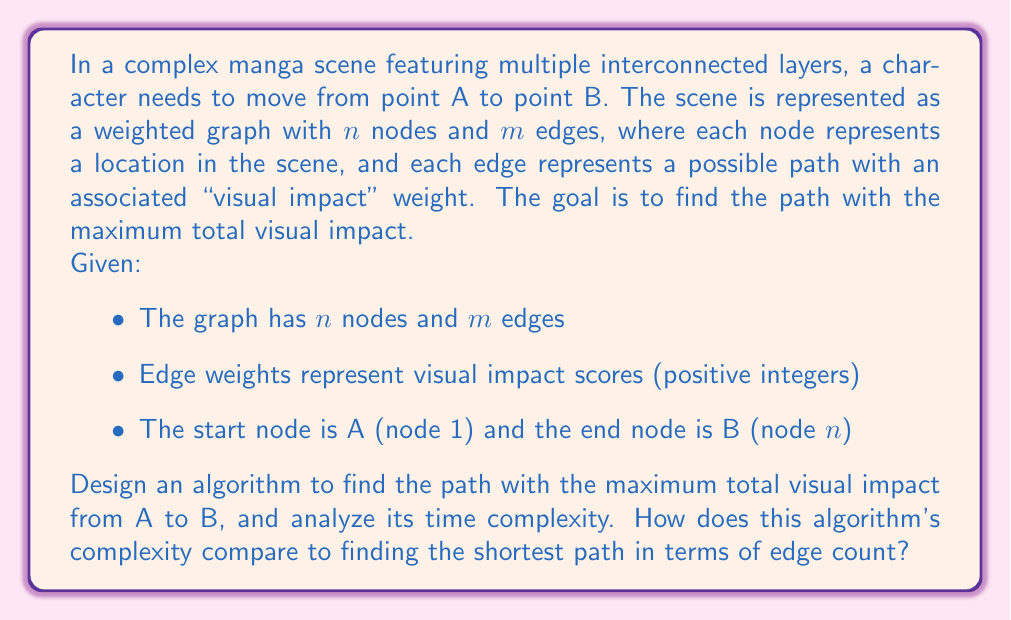Give your solution to this math problem. To solve this problem, we can adapt Dijkstra's algorithm to find the path with maximum visual impact instead of the shortest path. Here's the step-by-step approach:

1. Initialize a priority queue PQ to store nodes and their maximum visual impact scores.
2. Create an array dist[1..n] to store the maximum visual impact to each node, initially set to -∞ for all nodes except dist[1] = 0.
3. Create an array prev[1..n] to store the previous node in the optimal path.
4. Insert the start node (1) into PQ with priority 0.
5. While PQ is not empty:
   a. Extract the node u with the highest priority (max visual impact) from PQ.
   b. If u is the end node (n), terminate the algorithm.
   c. For each neighbor v of u:
      - Calculate new_impact = dist[u] + weight(u, v)
      - If new_impact > dist[v]:
        * Update dist[v] = new_impact
        * Update prev[v] = u
        * Insert v into PQ with priority new_impact (or update its priority if already in PQ)
6. Reconstruct the path using the prev array.

Time Complexity Analysis:
- Extracting from PQ: O(log m) per operation
- Total extractions: O(m log m)
- Updating neighbors: O(m log m)
- Overall time complexity: O(m log m)

Space Complexity: O(n + m) for the graph representation and additional data structures.

Comparison to Shortest Path:
The time complexity for finding the maximum visual impact path is the same as finding the shortest path using Dijkstra's algorithm: O(m log m). The main difference is in the relaxation step, where we maximize the total weight instead of minimizing it.

In the context of manga translation, this algorithm allows the artist to determine the most visually impactful path for character movement, enhancing the overall visual storytelling of the scene.
Answer: The optimal algorithm to find the path with maximum visual impact has a time complexity of O(m log m), where m is the number of edges in the graph. This is the same complexity as Dijkstra's algorithm for finding the shortest path, but adapted to maximize the total weight (visual impact) instead of minimizing it. 